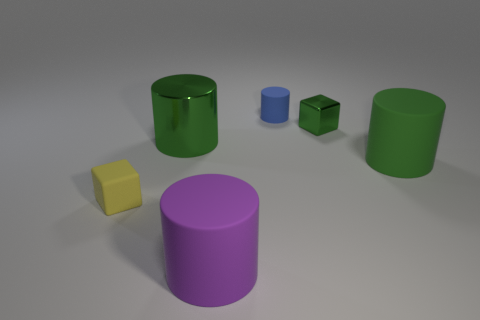Subtract all big purple cylinders. How many cylinders are left? 3 Subtract all yellow spheres. How many green cylinders are left? 2 Subtract all blue cylinders. How many cylinders are left? 3 Add 1 large gray cubes. How many objects exist? 7 Subtract all cylinders. How many objects are left? 2 Subtract all large green metal things. Subtract all green cylinders. How many objects are left? 3 Add 5 blue rubber cylinders. How many blue rubber cylinders are left? 6 Add 4 yellow rubber blocks. How many yellow rubber blocks exist? 5 Subtract 0 yellow cylinders. How many objects are left? 6 Subtract all yellow cubes. Subtract all red cylinders. How many cubes are left? 1 